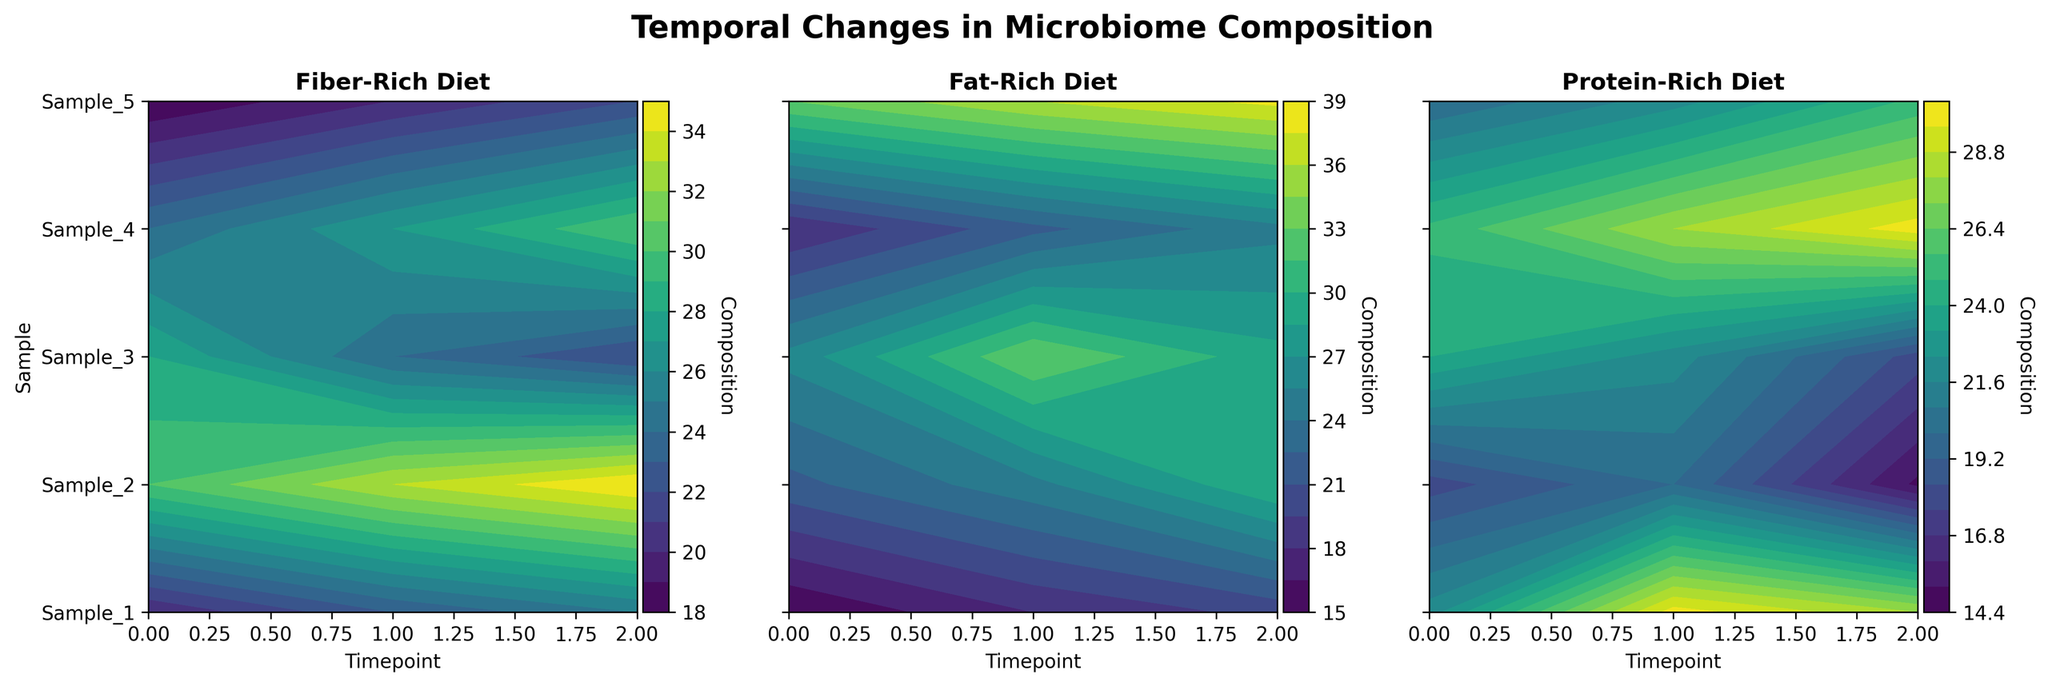What is the title of the figure? The title is displayed at the top center of the figure, which reads "Temporal Changes in Microbiome Composition".
Answer: Temporal Changes in Microbiome Composition What diets are shown in the subplots? The titles above each subplot indicate the three different types of diets being analyzed: Fiber-Rich, Fat-Rich, and Protein-Rich.
Answer: Fiber-Rich, Fat-Rich, and Protein-Rich Which sample had the highest microbiome composition at timepoint 0 for the Fiber-Rich diet? From the contour plot for the Fiber-Rich diet, find the values at timepoint 0. Sample_2 has the highest value of 30.
Answer: Sample_2 Comparing the Fat-Rich diet, was there an increase or decrease in microbiome composition for Sample_3 from timepoint 0 to timepoint 1? In the Fat-Rich diet plot, observe Sample_3's values at timepoints 0 (26) and 1 (33). Since 33 is greater than 26, it indicates an increase.
Answer: Increase What interval of time is shown on the x-axis of all subplots? The x-axis of all subplots is labeled "Timepoint" and ranges from 0 to 2.
Answer: 0 to 2 Which sample showed the most significant decrease in microbiome composition in the Protein-Rich diet from timepoint 1 to timepoint 2? For the Protein-Rich plot, compare the values from timepoint 1 to timepoint 2 for each sample. Sample_2 had the largest decrease from 20 to 15.
Answer: Sample_2 How many samples are displayed in each subplot? By counting the tick labels on the y-axis of each subplot, it can be seen that there are 5 samples: Sample_1, Sample_2, Sample_3, Sample_4, and Sample_5.
Answer: 5 Between the Fiber-Rich and Fat-Rich diets, which one had a greater change in microbiome composition for Sample_1 from timepoint 0 to timepoint 2? Fiber-Rich changes from 20 to 25 (a change of 5), and Fat-Rich changes from 15 to 20 (a change of 5). Both had the same change of 5.
Answer: Same change Which diet showed the highest peak in microbiome composition across all samples and timepoints? The highest value on all plots was for the Fat-Rich diet where Sample_5 at timepoint 2 reaches a value of 38.
Answer: Fat-Rich diet What is the average microbiome composition at timepoint 1 for the Protein-Rich diet? For timepoint 1 in the Protein-Rich diet, the values are 30, 20, 22, 28, and 22. Sum these values (30 + 20 + 22 + 28 + 22 = 122) and divide by the number of samples (5). 122 / 5 = 24.4.
Answer: 24.4 